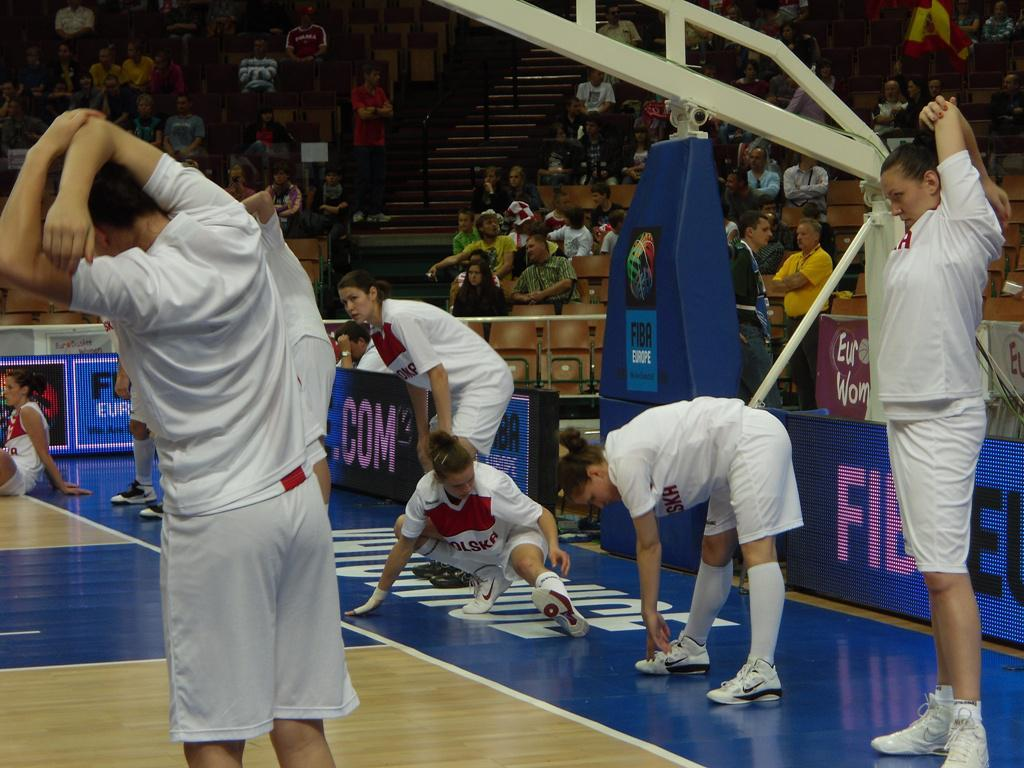What are the people in the image doing? There are people standing and sitting in chairs in the image. What can be seen on the boards in the image? There are boards with text in the image. What type of twig is being used as a prop in the image? There is no twig present in the image. How does the stomach of the person sitting in the chair look in the image? The image does not show the stomachs of the people, so it cannot be determined from the image. 